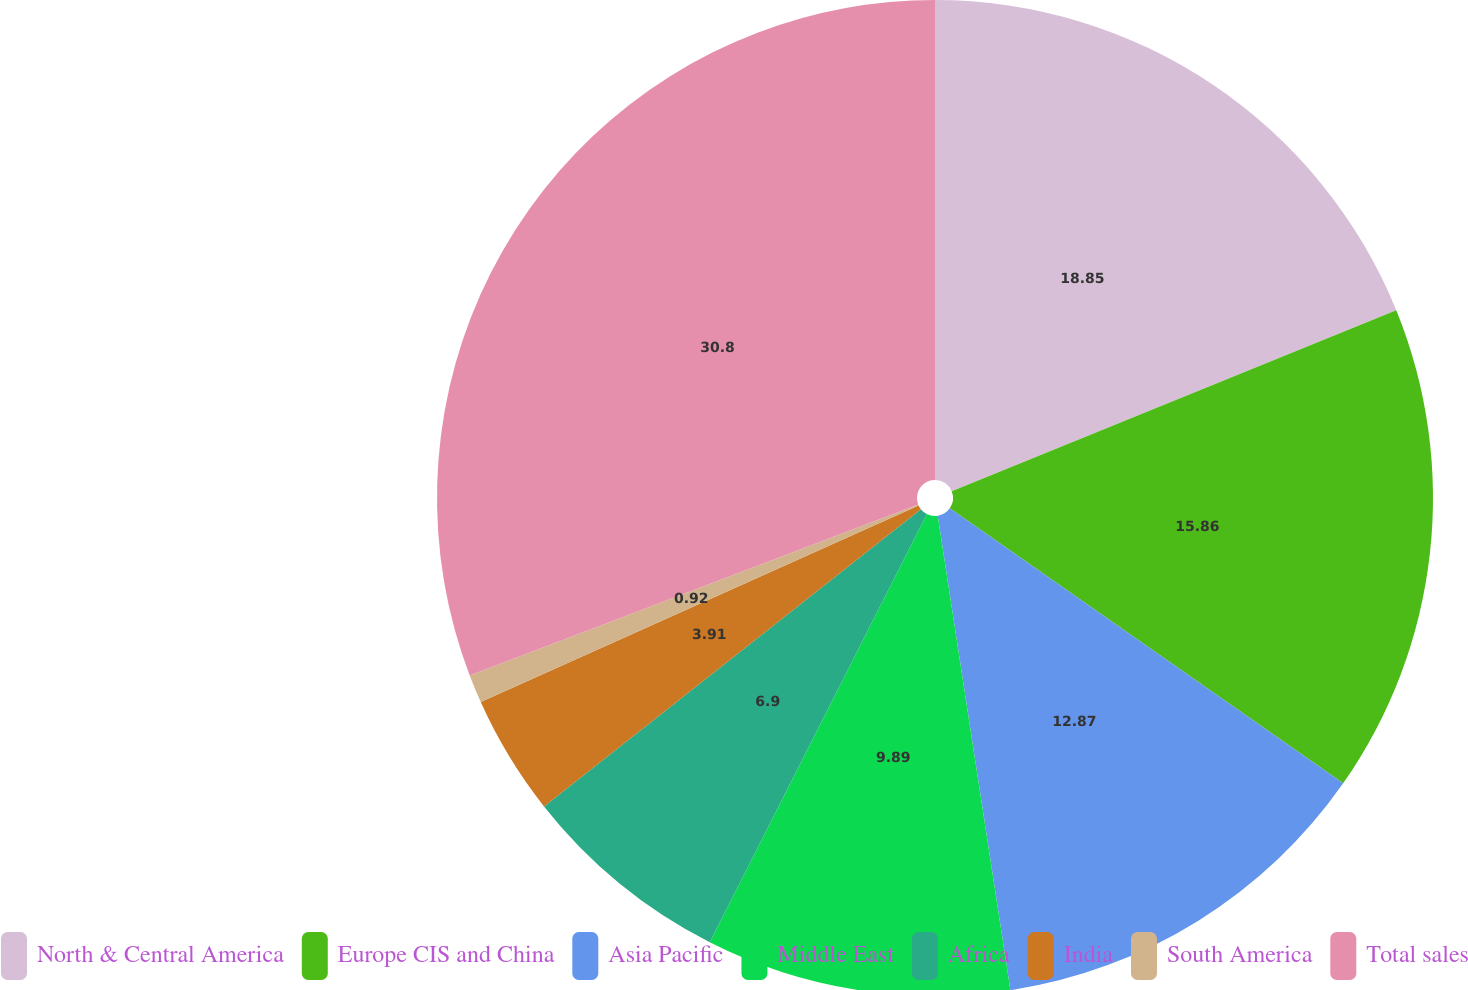Convert chart to OTSL. <chart><loc_0><loc_0><loc_500><loc_500><pie_chart><fcel>North & Central America<fcel>Europe CIS and China<fcel>Asia Pacific<fcel>Middle East<fcel>Africa<fcel>India<fcel>South America<fcel>Total sales<nl><fcel>18.85%<fcel>15.86%<fcel>12.87%<fcel>9.89%<fcel>6.9%<fcel>3.91%<fcel>0.92%<fcel>30.8%<nl></chart> 